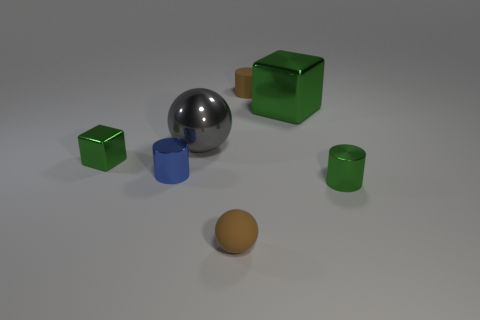Subtract all tiny green metal cylinders. How many cylinders are left? 2 Add 3 metal blocks. How many objects exist? 10 Subtract all gray cylinders. Subtract all red spheres. How many cylinders are left? 3 Subtract all spheres. How many objects are left? 5 Subtract 0 brown blocks. How many objects are left? 7 Subtract all purple cylinders. Subtract all green metal cylinders. How many objects are left? 6 Add 3 small green cylinders. How many small green cylinders are left? 4 Add 5 cylinders. How many cylinders exist? 8 